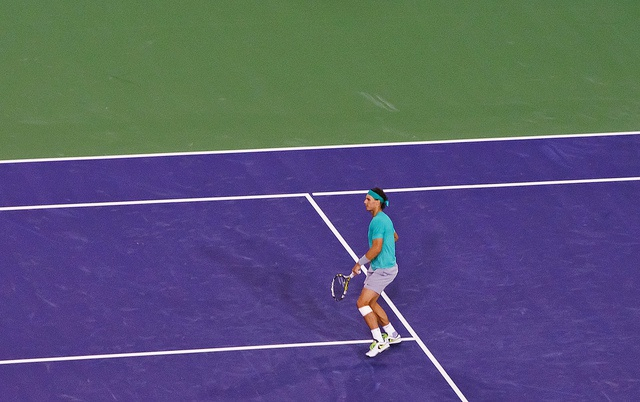Describe the objects in this image and their specific colors. I can see people in green, lavender, purple, teal, and brown tones and tennis racket in green, purple, and navy tones in this image. 